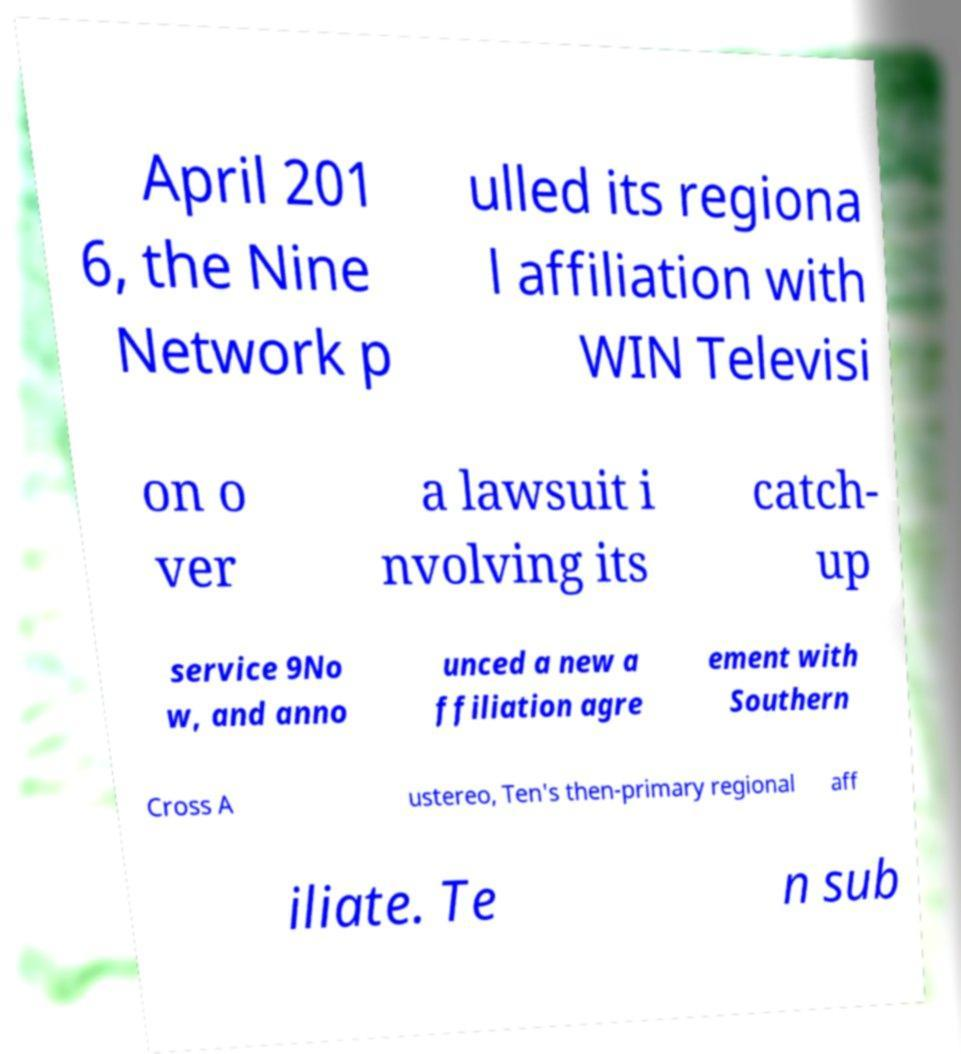Please identify and transcribe the text found in this image. April 201 6, the Nine Network p ulled its regiona l affiliation with WIN Televisi on o ver a lawsuit i nvolving its catch- up service 9No w, and anno unced a new a ffiliation agre ement with Southern Cross A ustereo, Ten's then-primary regional aff iliate. Te n sub 